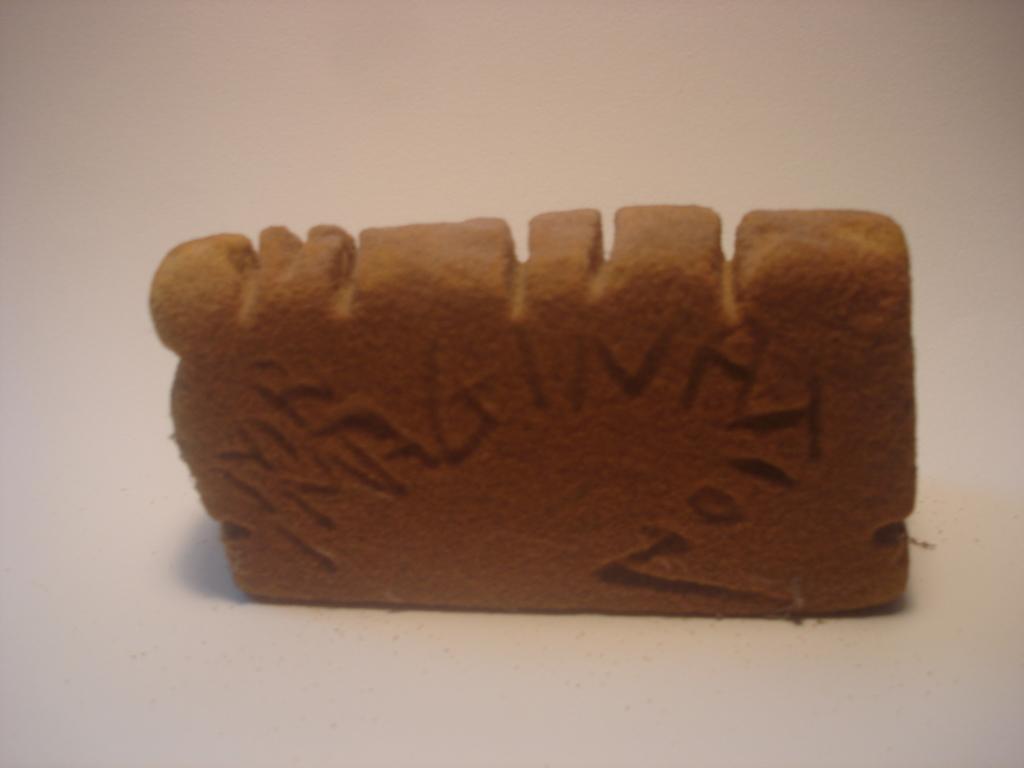Can you describe this image briefly? In this picture, we see an edible or a toy. It is in brown color. In the background, it is white in color. It might be a white table. 